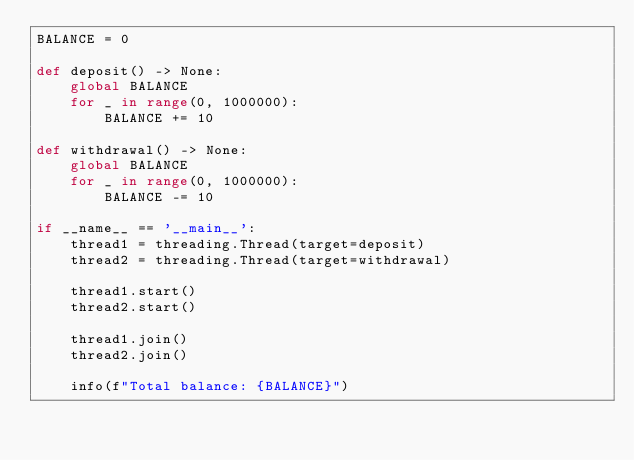Convert code to text. <code><loc_0><loc_0><loc_500><loc_500><_Python_>BALANCE = 0

def deposit() -> None:
    global BALANCE
    for _ in range(0, 1000000):
        BALANCE += 10

def withdrawal() -> None:
    global BALANCE
    for _ in range(0, 1000000):
        BALANCE -= 10

if __name__ == '__main__':
    thread1 = threading.Thread(target=deposit)
    thread2 = threading.Thread(target=withdrawal)

    thread1.start()
    thread2.start()

    thread1.join()
    thread2.join()

    info(f"Total balance: {BALANCE}")
</code> 